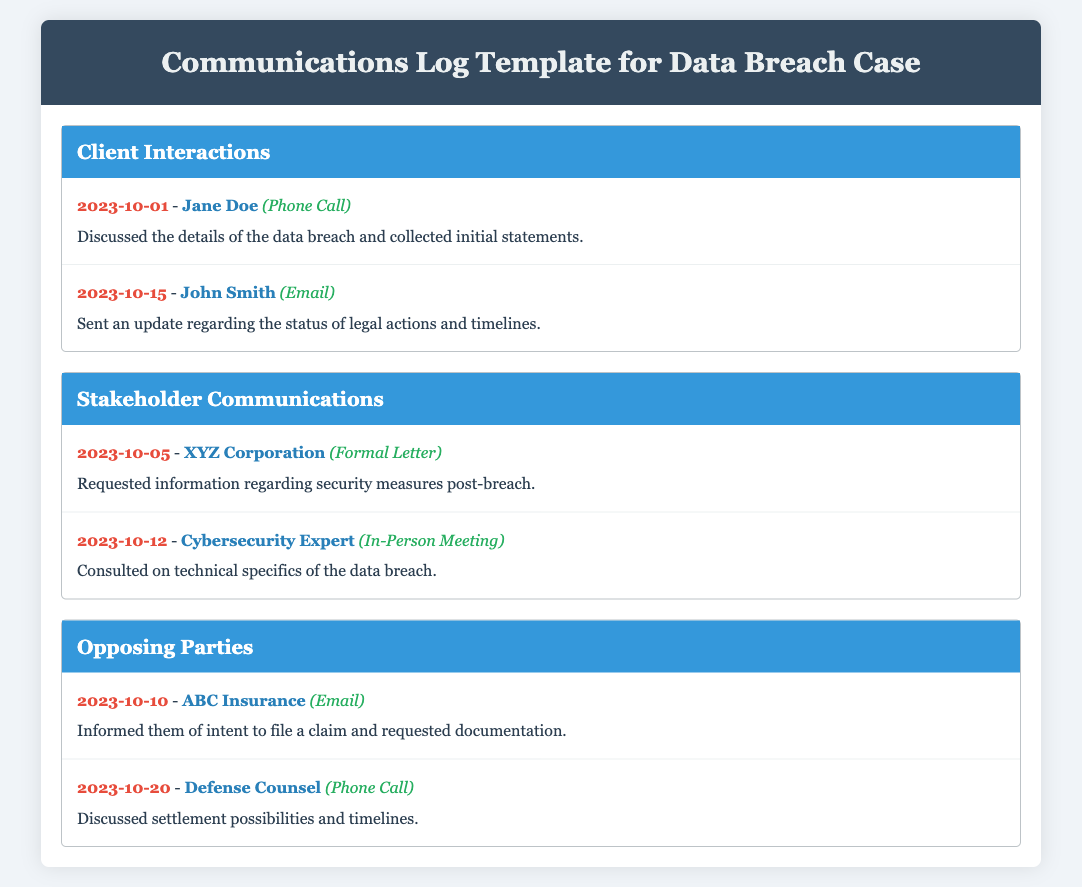What is the title of the document? The title of the document can be found in the header section, which provides a clear indication of the content.
Answer: Communications Log Template for Data Breach Case Who is the client mentioned on 2023-10-01? The client mentioned in the log for this date is specifically listed after the log date and before the method of communication.
Answer: Jane Doe What method was used to communicate with John Smith? The method of communication is indicated right after John's name in the log, specifying how the interaction occurred.
Answer: Email On which date was the communication with XYZ Corporation? The date is recorded next to the log entry for the stakeholder, providing clarity on the timeline of interactions.
Answer: 2023-10-05 How many interactions are recorded under Client Interactions? The number can be determined by counting the log items listed in the designated section of the document.
Answer: 2 What was the main topic of the meeting with the Cybersecurity Expert? The main topic is described in the summary of the log entry, which outlines the purpose of the communication.
Answer: Technical specifics of the data breach When did the communication with Defense Counsel take place? The date for this communication can be found directly in the log next to the entry for Defense Counsel.
Answer: 2023-10-20 What type of communication was used with ABC Insurance? The type of communication is explicitly detailed in the log entry under the method used for the interaction.
Answer: Email 